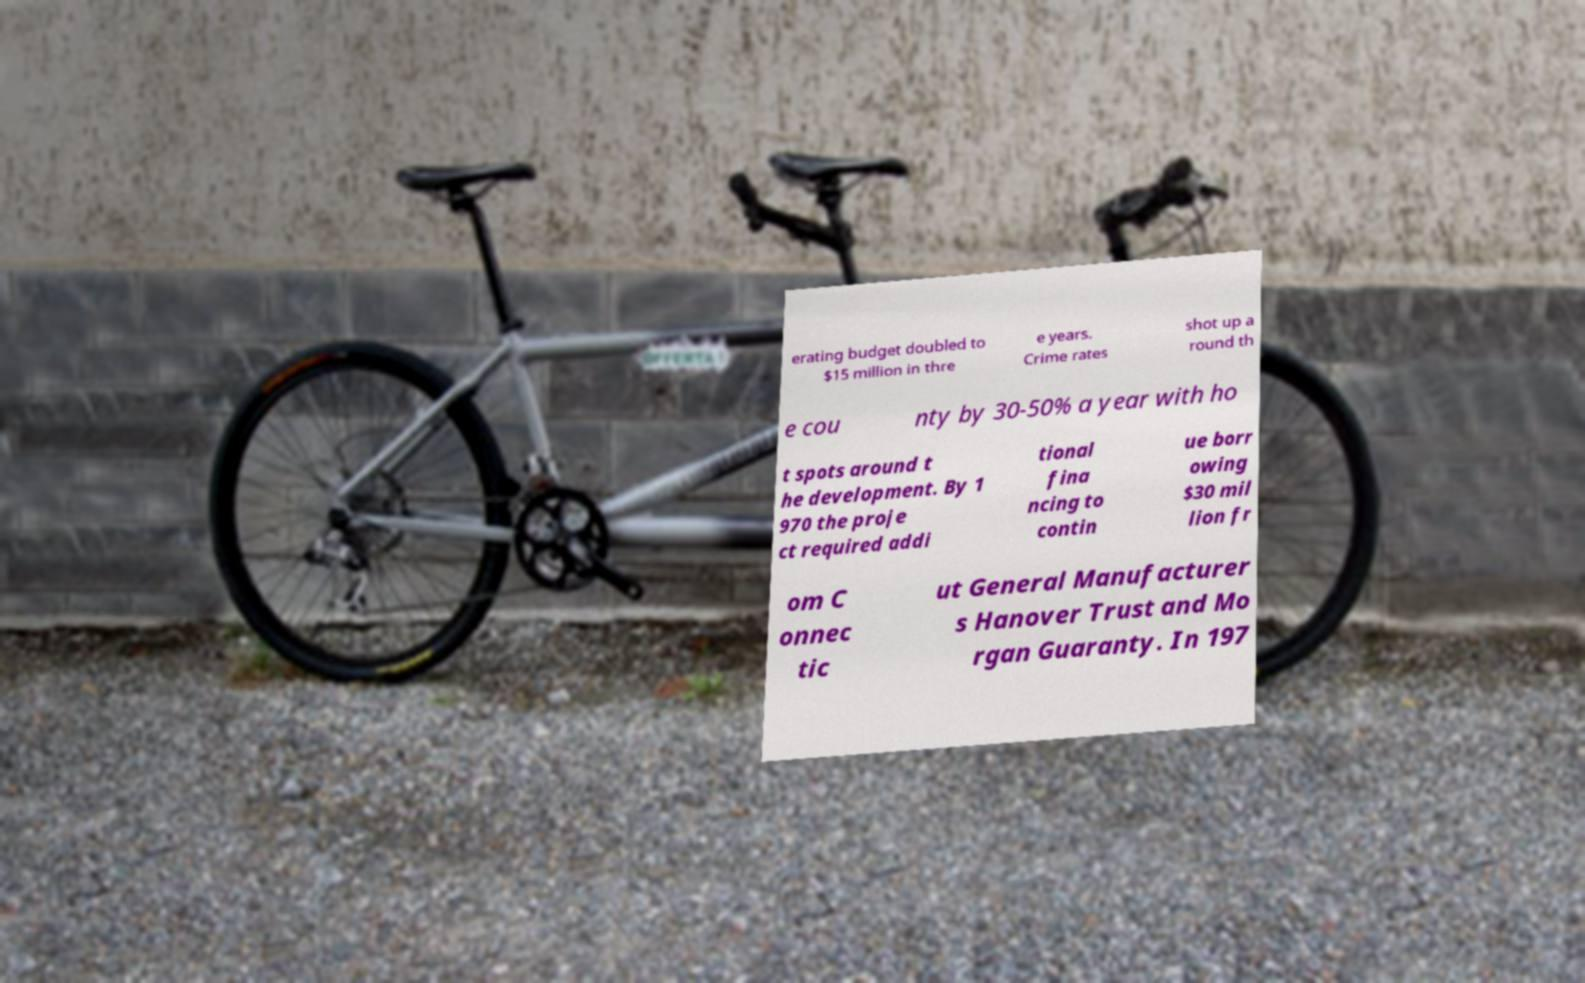For documentation purposes, I need the text within this image transcribed. Could you provide that? erating budget doubled to $15 million in thre e years. Crime rates shot up a round th e cou nty by 30-50% a year with ho t spots around t he development. By 1 970 the proje ct required addi tional fina ncing to contin ue borr owing $30 mil lion fr om C onnec tic ut General Manufacturer s Hanover Trust and Mo rgan Guaranty. In 197 